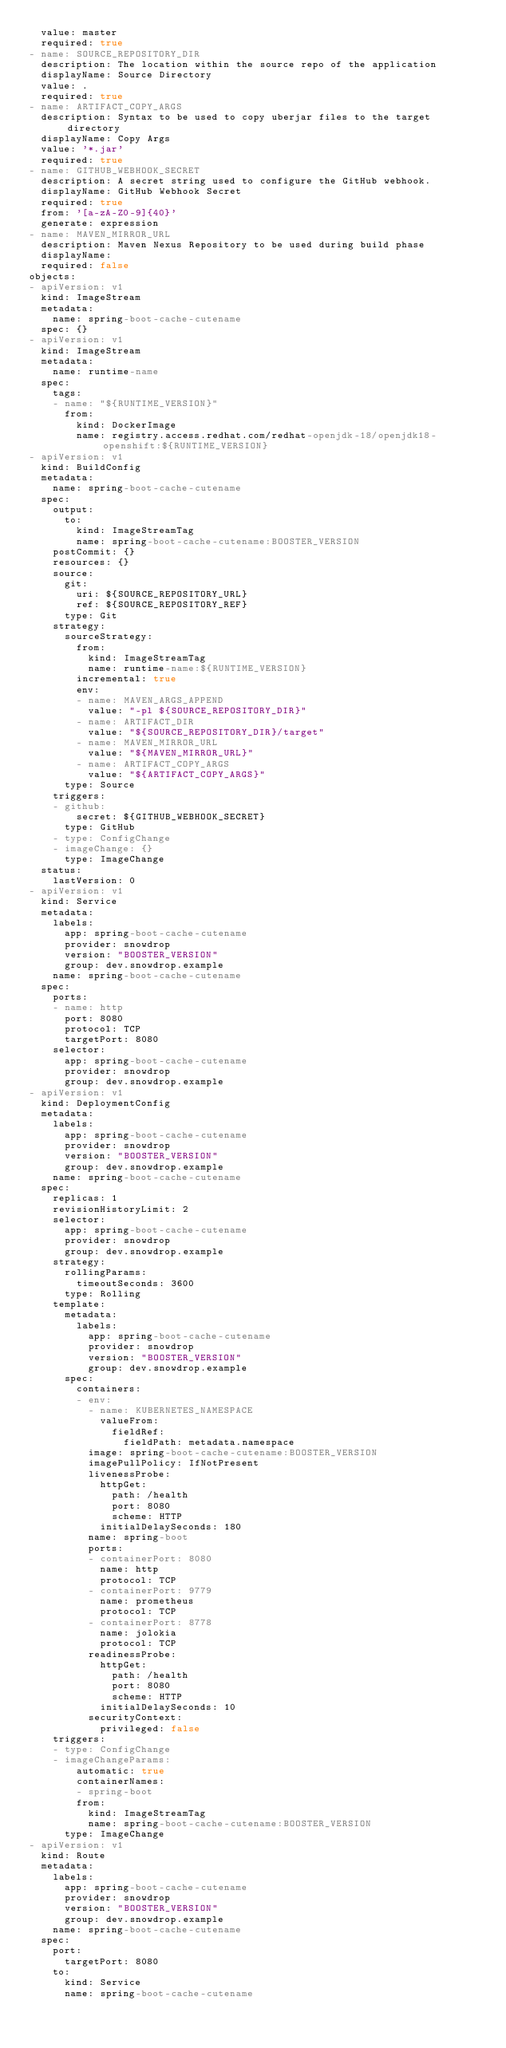Convert code to text. <code><loc_0><loc_0><loc_500><loc_500><_YAML_>  value: master
  required: true
- name: SOURCE_REPOSITORY_DIR
  description: The location within the source repo of the application
  displayName: Source Directory
  value: .
  required: true
- name: ARTIFACT_COPY_ARGS
  description: Syntax to be used to copy uberjar files to the target directory
  displayName: Copy Args
  value: '*.jar'
  required: true
- name: GITHUB_WEBHOOK_SECRET
  description: A secret string used to configure the GitHub webhook.
  displayName: GitHub Webhook Secret
  required: true
  from: '[a-zA-Z0-9]{40}'
  generate: expression
- name: MAVEN_MIRROR_URL
  description: Maven Nexus Repository to be used during build phase
  displayName:
  required: false
objects:
- apiVersion: v1
  kind: ImageStream
  metadata:
    name: spring-boot-cache-cutename
  spec: {}
- apiVersion: v1
  kind: ImageStream
  metadata:
    name: runtime-name
  spec:
    tags:
    - name: "${RUNTIME_VERSION}"
      from:
        kind: DockerImage
        name: registry.access.redhat.com/redhat-openjdk-18/openjdk18-openshift:${RUNTIME_VERSION}
- apiVersion: v1
  kind: BuildConfig
  metadata:
    name: spring-boot-cache-cutename
  spec:
    output:
      to:
        kind: ImageStreamTag
        name: spring-boot-cache-cutename:BOOSTER_VERSION
    postCommit: {}
    resources: {}
    source:
      git:
        uri: ${SOURCE_REPOSITORY_URL}
        ref: ${SOURCE_REPOSITORY_REF}
      type: Git
    strategy:
      sourceStrategy:
        from:
          kind: ImageStreamTag
          name: runtime-name:${RUNTIME_VERSION}
        incremental: true
        env:
        - name: MAVEN_ARGS_APPEND
          value: "-pl ${SOURCE_REPOSITORY_DIR}"
        - name: ARTIFACT_DIR
          value: "${SOURCE_REPOSITORY_DIR}/target"
        - name: MAVEN_MIRROR_URL
          value: "${MAVEN_MIRROR_URL}"
        - name: ARTIFACT_COPY_ARGS
          value: "${ARTIFACT_COPY_ARGS}"
      type: Source
    triggers:
    - github:
        secret: ${GITHUB_WEBHOOK_SECRET}
      type: GitHub
    - type: ConfigChange
    - imageChange: {}
      type: ImageChange
  status:
    lastVersion: 0
- apiVersion: v1
  kind: Service
  metadata:
    labels:
      app: spring-boot-cache-cutename
      provider: snowdrop
      version: "BOOSTER_VERSION"
      group: dev.snowdrop.example
    name: spring-boot-cache-cutename
  spec:
    ports:
    - name: http
      port: 8080
      protocol: TCP
      targetPort: 8080
    selector:
      app: spring-boot-cache-cutename
      provider: snowdrop
      group: dev.snowdrop.example
- apiVersion: v1
  kind: DeploymentConfig
  metadata:
    labels:
      app: spring-boot-cache-cutename
      provider: snowdrop
      version: "BOOSTER_VERSION"
      group: dev.snowdrop.example
    name: spring-boot-cache-cutename
  spec:
    replicas: 1
    revisionHistoryLimit: 2
    selector:
      app: spring-boot-cache-cutename
      provider: snowdrop
      group: dev.snowdrop.example
    strategy:
      rollingParams:
        timeoutSeconds: 3600
      type: Rolling
    template:
      metadata:
        labels:
          app: spring-boot-cache-cutename
          provider: snowdrop
          version: "BOOSTER_VERSION"
          group: dev.snowdrop.example
      spec:
        containers:
        - env:
          - name: KUBERNETES_NAMESPACE
            valueFrom:
              fieldRef:
                fieldPath: metadata.namespace
          image: spring-boot-cache-cutename:BOOSTER_VERSION
          imagePullPolicy: IfNotPresent
          livenessProbe:
            httpGet:
              path: /health
              port: 8080
              scheme: HTTP
            initialDelaySeconds: 180
          name: spring-boot
          ports:
          - containerPort: 8080
            name: http
            protocol: TCP
          - containerPort: 9779
            name: prometheus
            protocol: TCP
          - containerPort: 8778
            name: jolokia
            protocol: TCP
          readinessProbe:
            httpGet:
              path: /health
              port: 8080
              scheme: HTTP
            initialDelaySeconds: 10
          securityContext:
            privileged: false
    triggers:
    - type: ConfigChange
    - imageChangeParams:
        automatic: true
        containerNames:
        - spring-boot
        from:
          kind: ImageStreamTag
          name: spring-boot-cache-cutename:BOOSTER_VERSION
      type: ImageChange
- apiVersion: v1
  kind: Route
  metadata:
    labels:
      app: spring-boot-cache-cutename
      provider: snowdrop
      version: "BOOSTER_VERSION"
      group: dev.snowdrop.example
    name: spring-boot-cache-cutename
  spec:
    port:
      targetPort: 8080
    to:
      kind: Service
      name: spring-boot-cache-cutename
</code> 